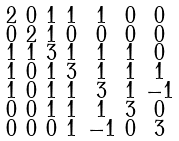Convert formula to latex. <formula><loc_0><loc_0><loc_500><loc_500>\begin{smallmatrix} 2 & 0 & 1 & 1 & 1 & 0 & 0 \\ 0 & 2 & 1 & 0 & 0 & 0 & 0 \\ 1 & 1 & 3 & 1 & 1 & 1 & 0 \\ 1 & 0 & 1 & 3 & 1 & 1 & 1 \\ 1 & 0 & 1 & 1 & 3 & 1 & - 1 \\ 0 & 0 & 1 & 1 & 1 & 3 & 0 \\ 0 & 0 & 0 & 1 & - 1 & 0 & 3 \end{smallmatrix}</formula> 